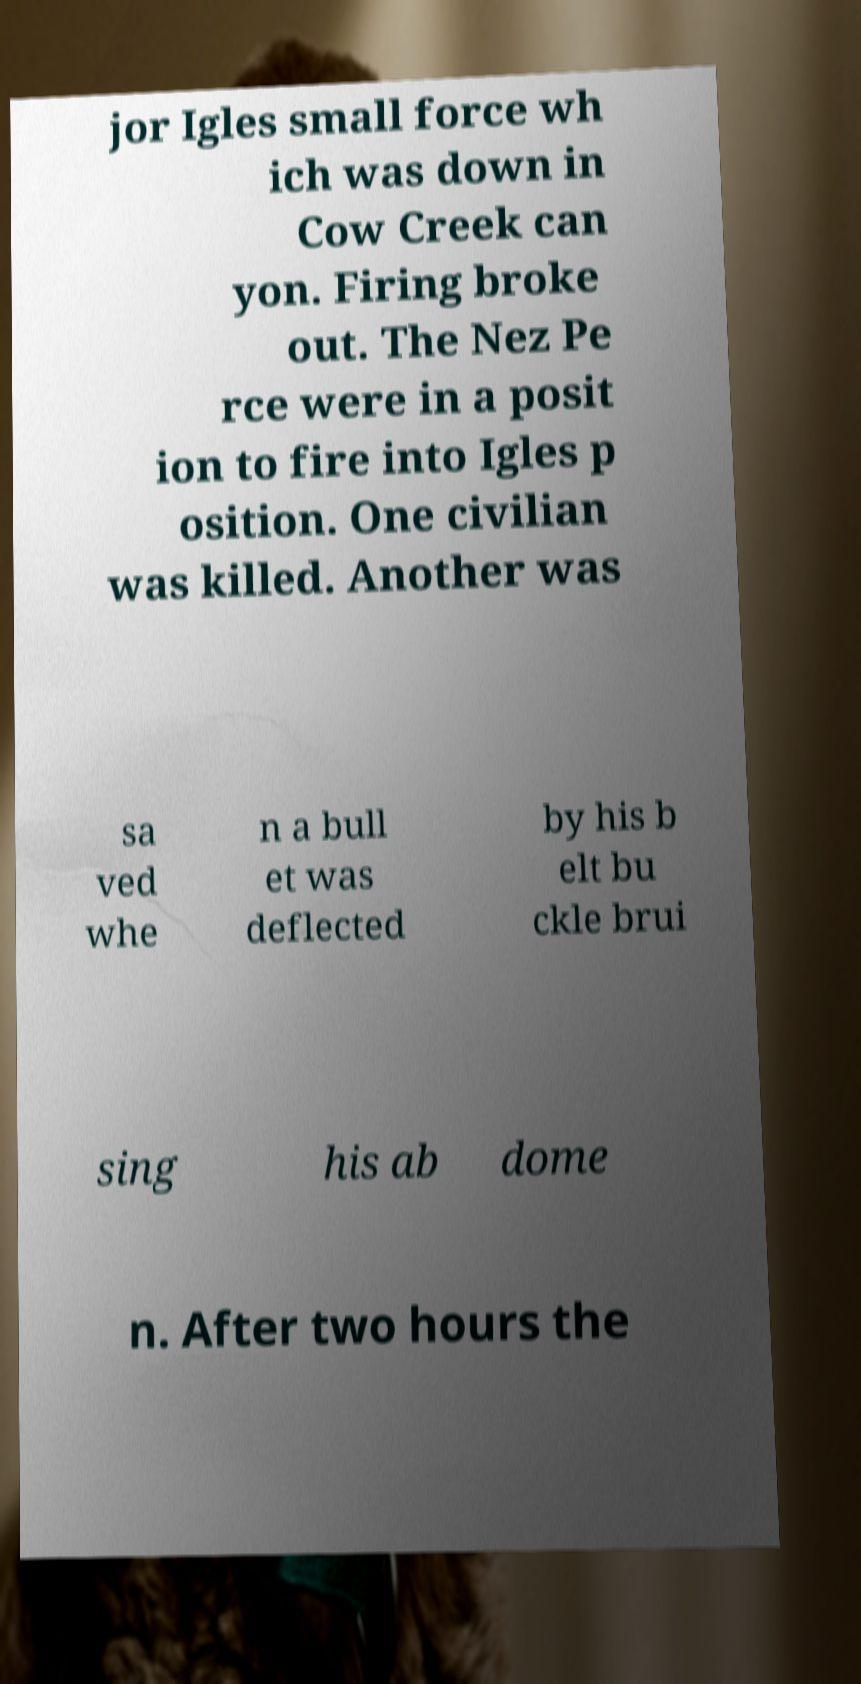I need the written content from this picture converted into text. Can you do that? jor Igles small force wh ich was down in Cow Creek can yon. Firing broke out. The Nez Pe rce were in a posit ion to fire into Igles p osition. One civilian was killed. Another was sa ved whe n a bull et was deflected by his b elt bu ckle brui sing his ab dome n. After two hours the 